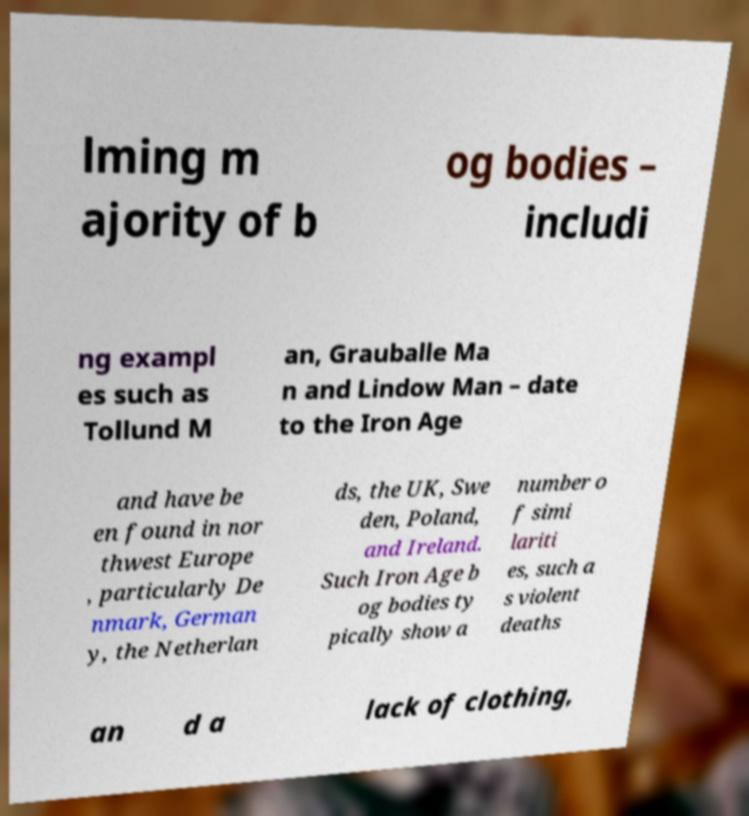What messages or text are displayed in this image? I need them in a readable, typed format. lming m ajority of b og bodies – includi ng exampl es such as Tollund M an, Grauballe Ma n and Lindow Man – date to the Iron Age and have be en found in nor thwest Europe , particularly De nmark, German y, the Netherlan ds, the UK, Swe den, Poland, and Ireland. Such Iron Age b og bodies ty pically show a number o f simi lariti es, such a s violent deaths an d a lack of clothing, 